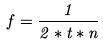Convert formula to latex. <formula><loc_0><loc_0><loc_500><loc_500>f = \frac { 1 } { 2 * t * n }</formula> 